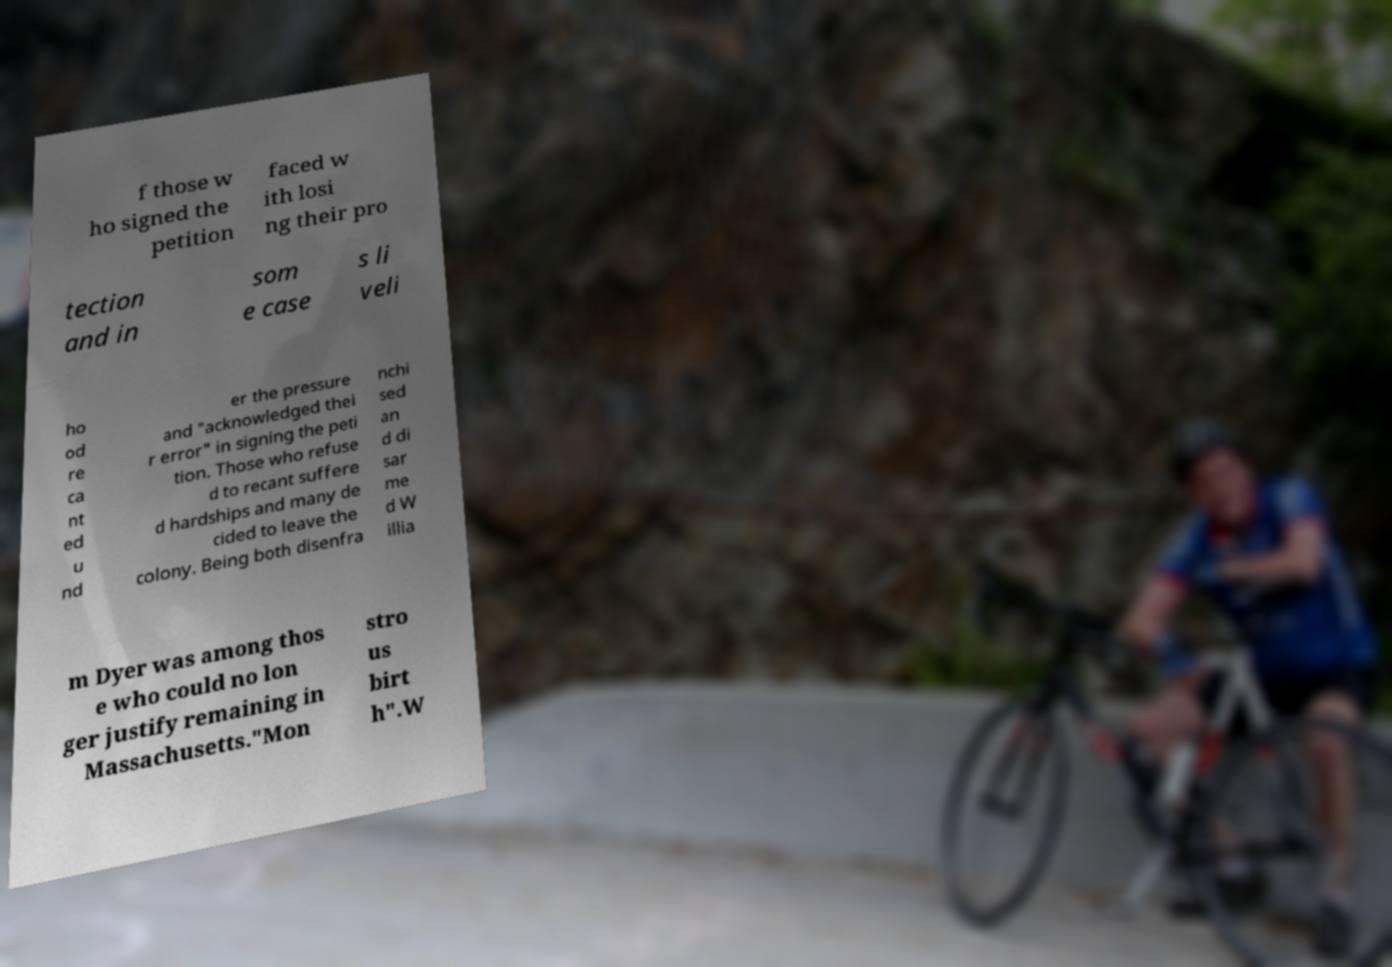Can you accurately transcribe the text from the provided image for me? f those w ho signed the petition faced w ith losi ng their pro tection and in som e case s li veli ho od re ca nt ed u nd er the pressure and "acknowledged thei r error" in signing the peti tion. Those who refuse d to recant suffere d hardships and many de cided to leave the colony. Being both disenfra nchi sed an d di sar me d W illia m Dyer was among thos e who could no lon ger justify remaining in Massachusetts."Mon stro us birt h".W 